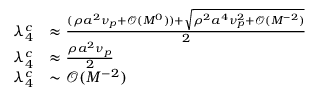<formula> <loc_0><loc_0><loc_500><loc_500>\begin{array} { r l } { \lambda _ { 4 } ^ { c } } & { \approx \frac { ( \rho a ^ { 2 } \nu _ { p } + \mathcal { O } ( M ^ { 0 } ) ) + \sqrt { \rho ^ { 2 } a ^ { 4 } \nu _ { p } ^ { 2 } + \mathcal { O } ( M ^ { - 2 } ) } } { 2 } } \\ { \lambda _ { 4 } ^ { c } } & { \approx \frac { \rho a ^ { 2 } \nu _ { p } } { 2 } } \\ { \lambda _ { 4 } ^ { c } } & { \sim \mathcal { O } ( M ^ { - 2 } ) } \end{array}</formula> 